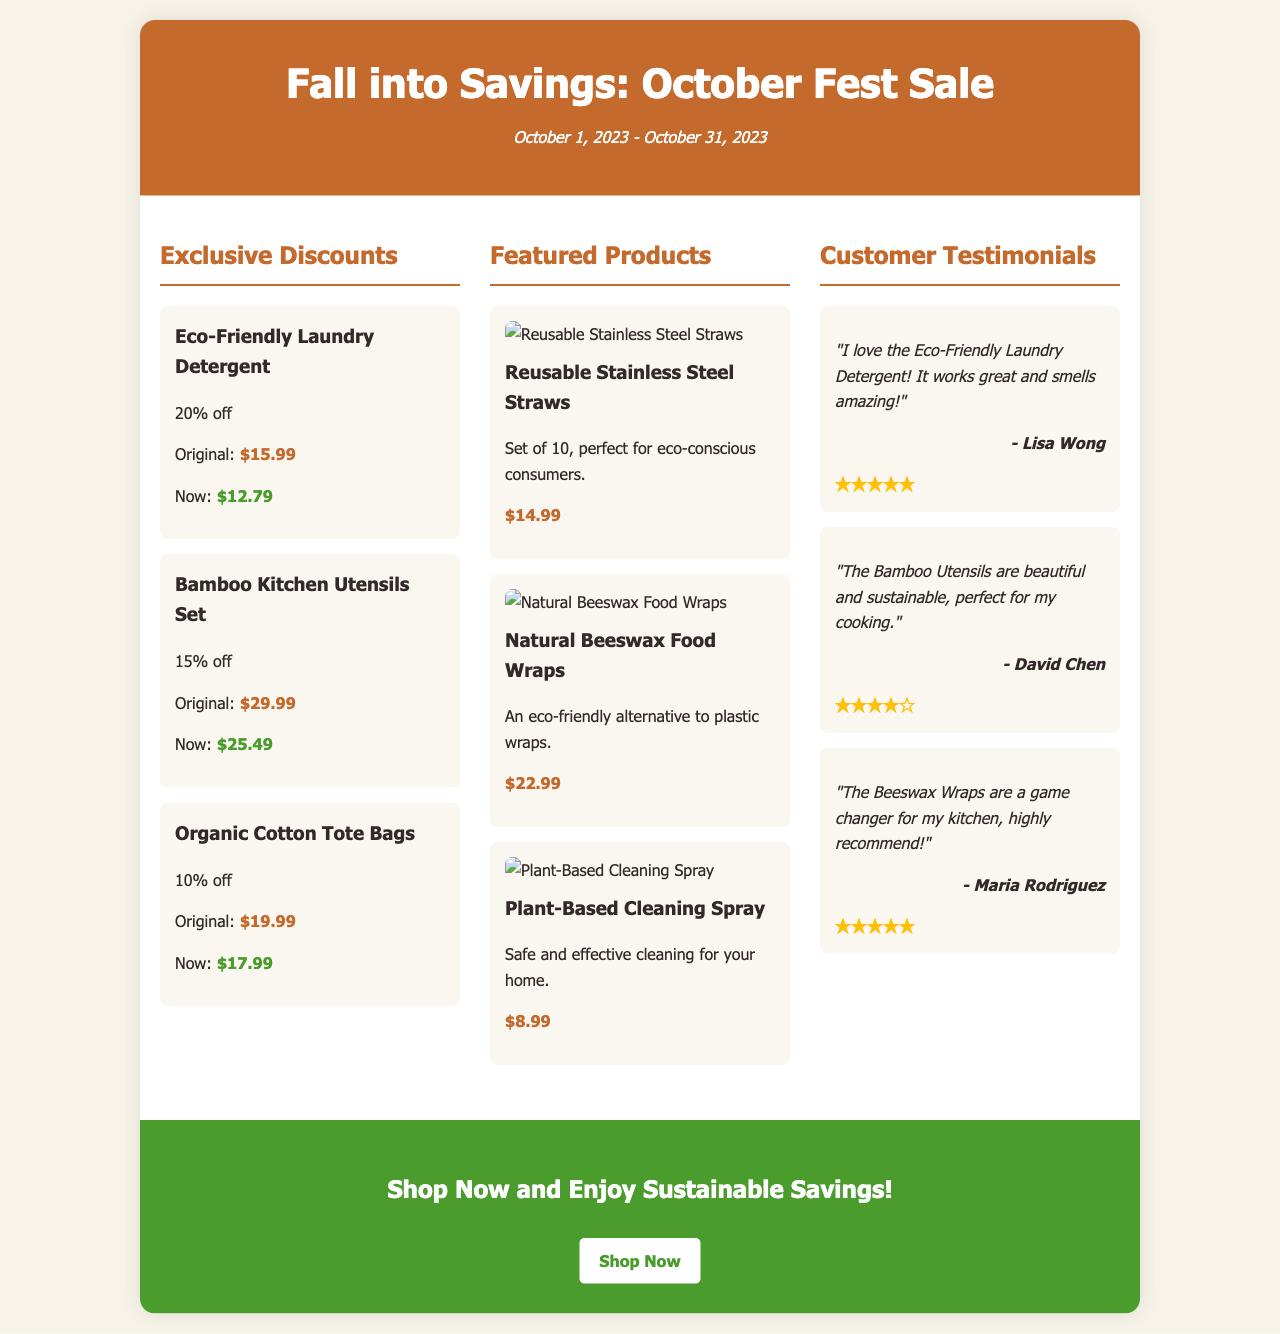What is the title of the promotion? The title of the promotion is prominently displayed in the header of the document.
Answer: Fall into Savings: October Fest Sale What are the dates of the promotion? The promotion period is listed under the title, indicating when it is active.
Answer: October 1, 2023 - October 31, 2023 What discount is offered on the Eco-Friendly Laundry Detergent? The discount information for each product is detailed under the "Exclusive Discounts" section.
Answer: 20% off What is the original price of the Bamboo Kitchen Utensils Set? The original price is provided alongside the discounts in the document.
Answer: $29.99 Which product is featured as a reusable alternative to plastic wraps? The featured products section lists various products, including this specific item.
Answer: Natural Beeswax Food Wraps Who gave a five-star testimonial for the Eco-Friendly Laundry Detergent? The testimonials provide customer feedback along with names and ratings, showing specific endorsements.
Answer: Lisa Wong Which product is described as "perfect for eco-conscious consumers"? The document includes specific descriptions for each featured product, aiding in identifying them easily.
Answer: Reusable Stainless Steel Straws What is the price of the Plant-Based Cleaning Spray? Each product's price is clearly indicated in the featured products section, facilitating quick reference.
Answer: $8.99 How many testimonials are provided in the document? The number of testimonial sections indicates the amount of customer feedback shared in this promotion.
Answer: 3 